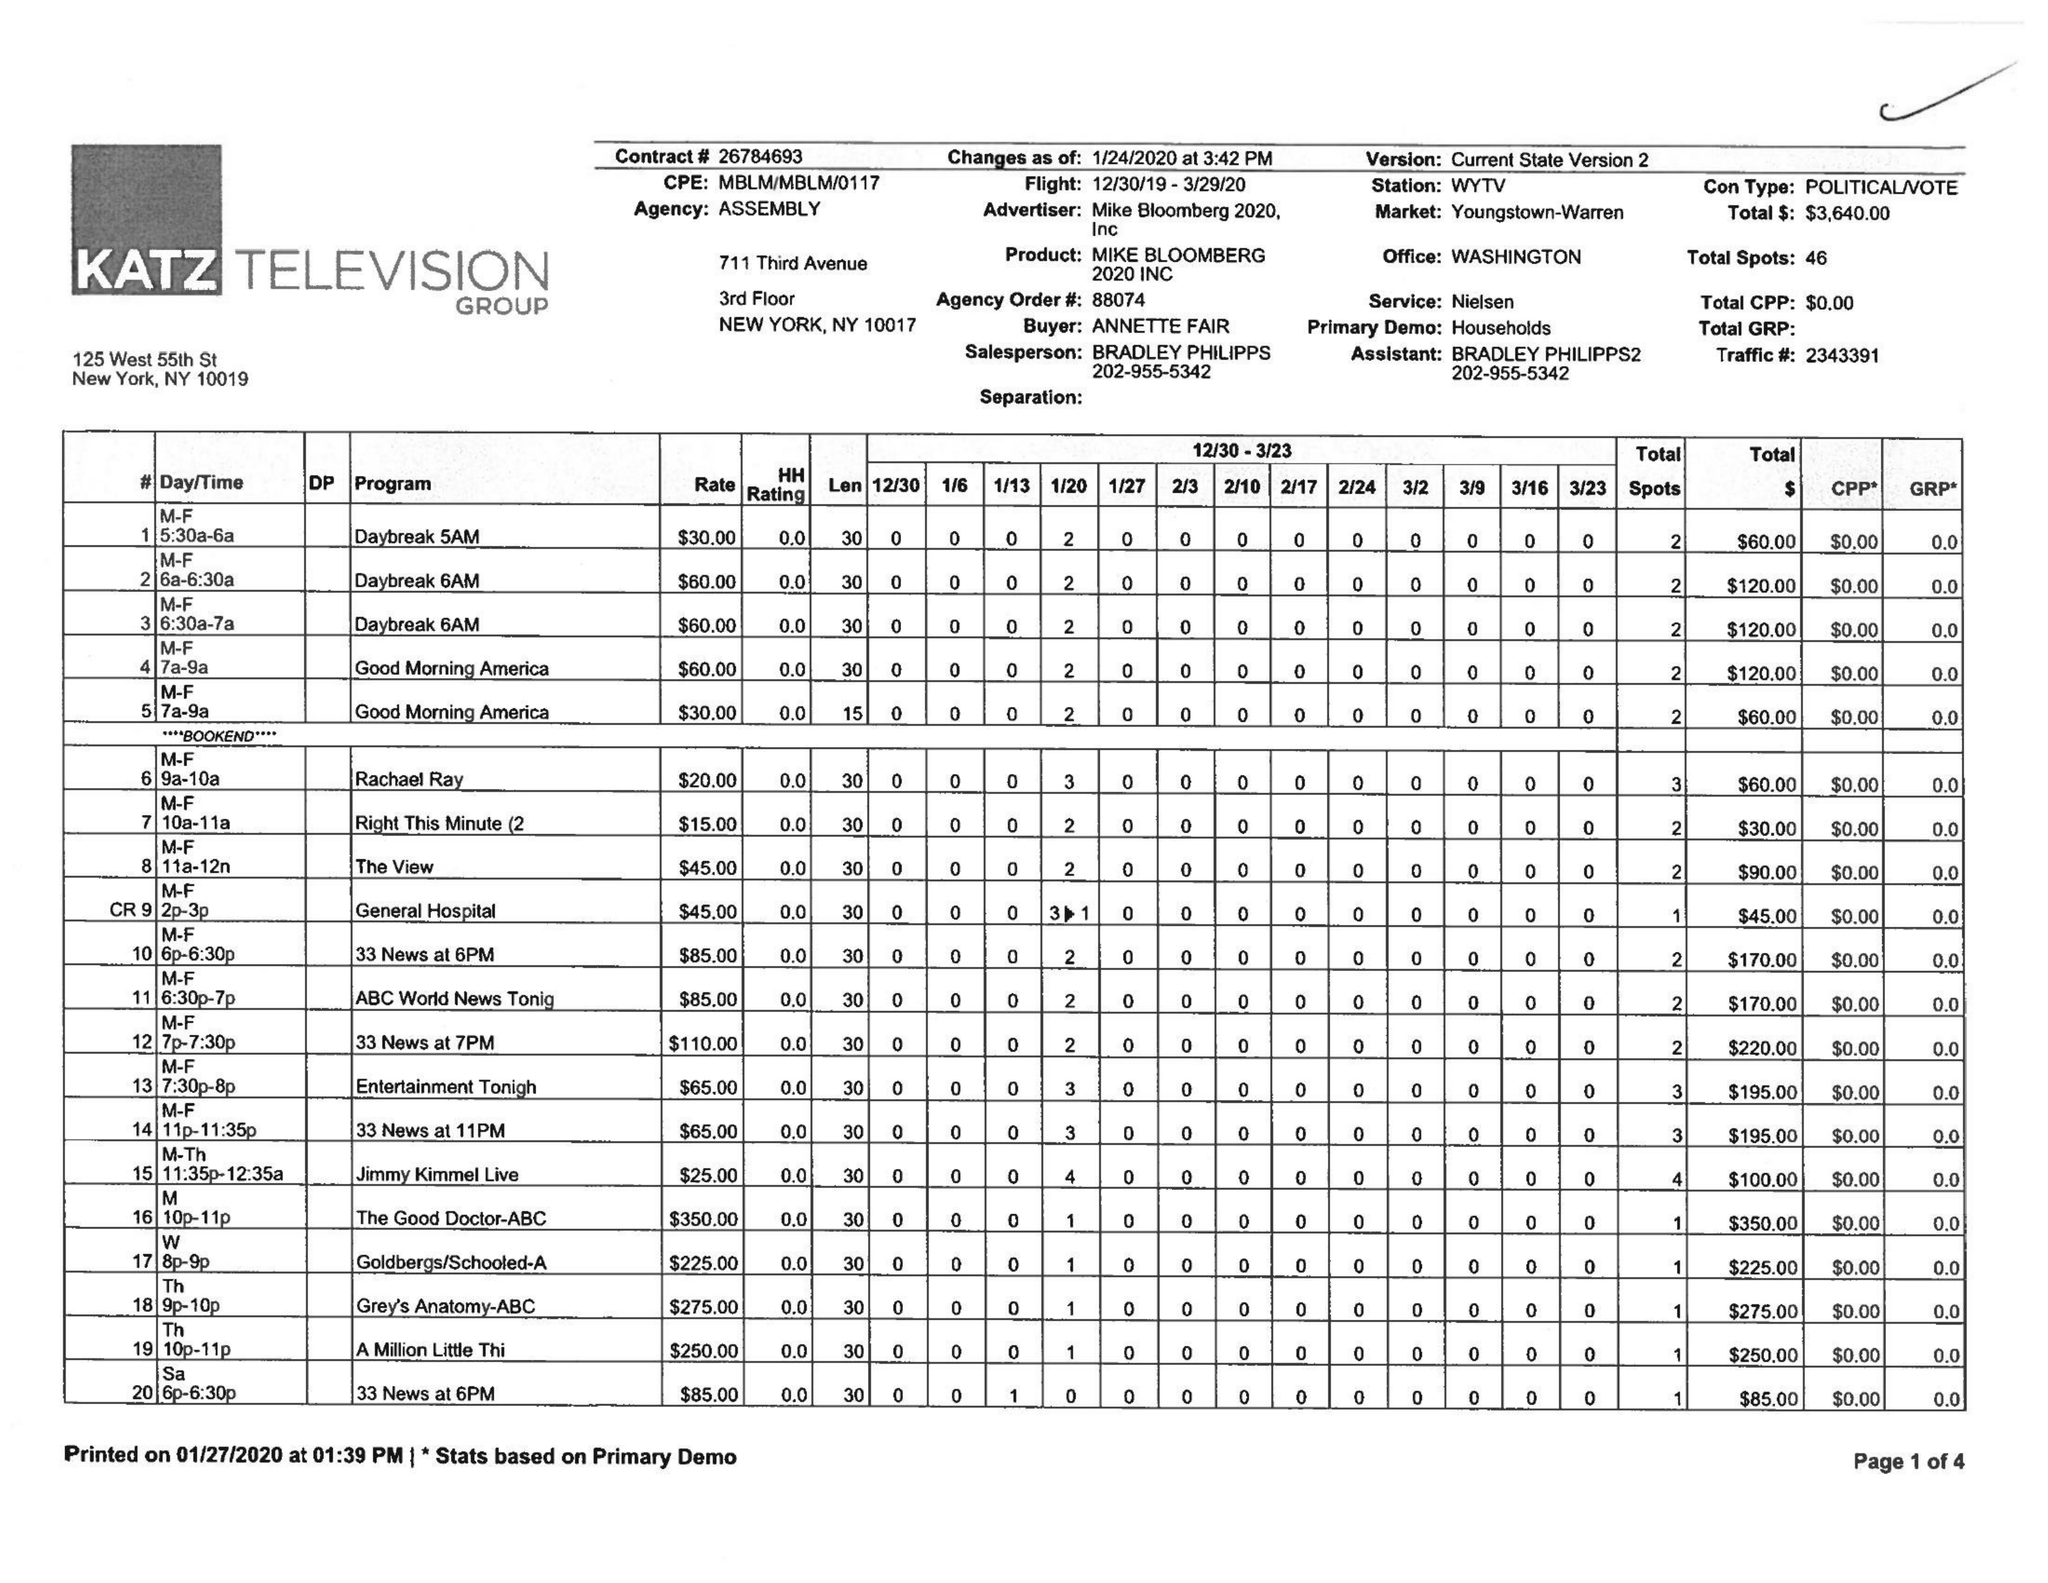What is the value for the contract_num?
Answer the question using a single word or phrase. 6784693 